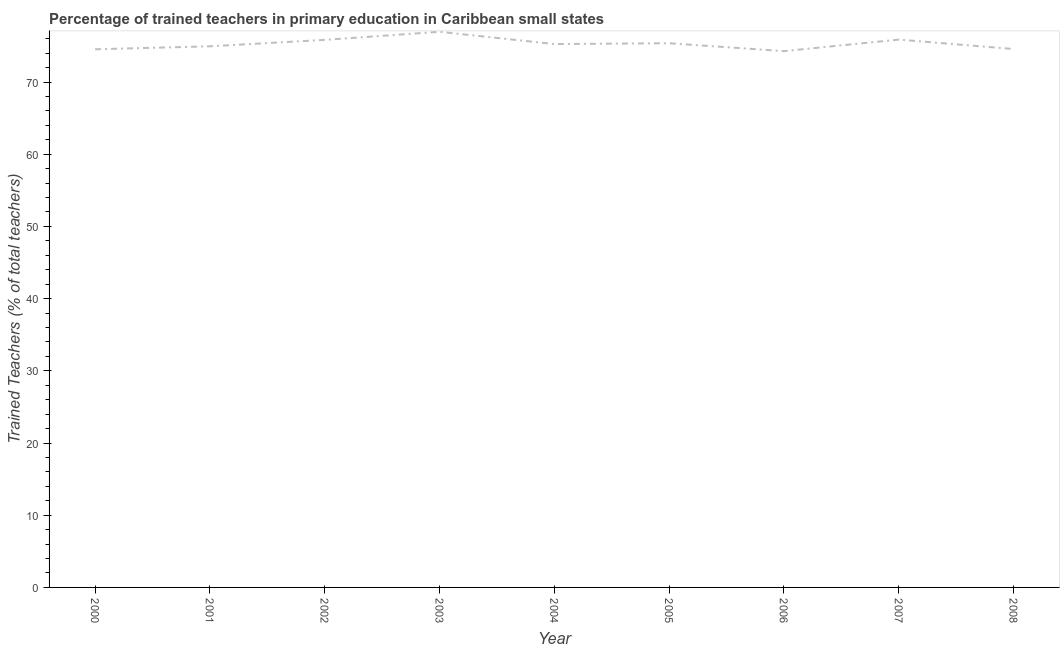What is the percentage of trained teachers in 2000?
Offer a terse response. 74.54. Across all years, what is the maximum percentage of trained teachers?
Offer a terse response. 76.96. Across all years, what is the minimum percentage of trained teachers?
Give a very brief answer. 74.28. What is the sum of the percentage of trained teachers?
Your response must be concise. 677.65. What is the difference between the percentage of trained teachers in 2004 and 2008?
Provide a short and direct response. 0.69. What is the average percentage of trained teachers per year?
Ensure brevity in your answer.  75.29. What is the median percentage of trained teachers?
Make the answer very short. 75.26. In how many years, is the percentage of trained teachers greater than 50 %?
Provide a succinct answer. 9. What is the ratio of the percentage of trained teachers in 2000 to that in 2003?
Your answer should be very brief. 0.97. Is the percentage of trained teachers in 2001 less than that in 2008?
Provide a succinct answer. No. What is the difference between the highest and the second highest percentage of trained teachers?
Provide a short and direct response. 1.08. Is the sum of the percentage of trained teachers in 2002 and 2006 greater than the maximum percentage of trained teachers across all years?
Your response must be concise. Yes. What is the difference between the highest and the lowest percentage of trained teachers?
Provide a succinct answer. 2.68. How many lines are there?
Offer a very short reply. 1. What is the difference between two consecutive major ticks on the Y-axis?
Your answer should be compact. 10. Are the values on the major ticks of Y-axis written in scientific E-notation?
Provide a succinct answer. No. What is the title of the graph?
Offer a terse response. Percentage of trained teachers in primary education in Caribbean small states. What is the label or title of the Y-axis?
Your response must be concise. Trained Teachers (% of total teachers). What is the Trained Teachers (% of total teachers) of 2000?
Provide a succinct answer. 74.54. What is the Trained Teachers (% of total teachers) in 2001?
Your answer should be compact. 74.95. What is the Trained Teachers (% of total teachers) of 2002?
Your answer should be very brief. 75.84. What is the Trained Teachers (% of total teachers) in 2003?
Give a very brief answer. 76.96. What is the Trained Teachers (% of total teachers) of 2004?
Your answer should be compact. 75.26. What is the Trained Teachers (% of total teachers) of 2005?
Your answer should be very brief. 75.38. What is the Trained Teachers (% of total teachers) in 2006?
Give a very brief answer. 74.28. What is the Trained Teachers (% of total teachers) in 2007?
Keep it short and to the point. 75.88. What is the Trained Teachers (% of total teachers) in 2008?
Your response must be concise. 74.57. What is the difference between the Trained Teachers (% of total teachers) in 2000 and 2001?
Provide a short and direct response. -0.41. What is the difference between the Trained Teachers (% of total teachers) in 2000 and 2002?
Provide a short and direct response. -1.3. What is the difference between the Trained Teachers (% of total teachers) in 2000 and 2003?
Keep it short and to the point. -2.42. What is the difference between the Trained Teachers (% of total teachers) in 2000 and 2004?
Ensure brevity in your answer.  -0.72. What is the difference between the Trained Teachers (% of total teachers) in 2000 and 2005?
Keep it short and to the point. -0.84. What is the difference between the Trained Teachers (% of total teachers) in 2000 and 2006?
Make the answer very short. 0.26. What is the difference between the Trained Teachers (% of total teachers) in 2000 and 2007?
Provide a succinct answer. -1.34. What is the difference between the Trained Teachers (% of total teachers) in 2000 and 2008?
Your answer should be compact. -0.04. What is the difference between the Trained Teachers (% of total teachers) in 2001 and 2002?
Your answer should be very brief. -0.89. What is the difference between the Trained Teachers (% of total teachers) in 2001 and 2003?
Your answer should be very brief. -2.01. What is the difference between the Trained Teachers (% of total teachers) in 2001 and 2004?
Give a very brief answer. -0.31. What is the difference between the Trained Teachers (% of total teachers) in 2001 and 2005?
Make the answer very short. -0.43. What is the difference between the Trained Teachers (% of total teachers) in 2001 and 2006?
Provide a short and direct response. 0.67. What is the difference between the Trained Teachers (% of total teachers) in 2001 and 2007?
Ensure brevity in your answer.  -0.93. What is the difference between the Trained Teachers (% of total teachers) in 2001 and 2008?
Offer a terse response. 0.37. What is the difference between the Trained Teachers (% of total teachers) in 2002 and 2003?
Ensure brevity in your answer.  -1.12. What is the difference between the Trained Teachers (% of total teachers) in 2002 and 2004?
Make the answer very short. 0.58. What is the difference between the Trained Teachers (% of total teachers) in 2002 and 2005?
Offer a terse response. 0.47. What is the difference between the Trained Teachers (% of total teachers) in 2002 and 2006?
Provide a short and direct response. 1.56. What is the difference between the Trained Teachers (% of total teachers) in 2002 and 2007?
Provide a short and direct response. -0.04. What is the difference between the Trained Teachers (% of total teachers) in 2002 and 2008?
Make the answer very short. 1.27. What is the difference between the Trained Teachers (% of total teachers) in 2003 and 2004?
Your answer should be very brief. 1.7. What is the difference between the Trained Teachers (% of total teachers) in 2003 and 2005?
Your response must be concise. 1.58. What is the difference between the Trained Teachers (% of total teachers) in 2003 and 2006?
Offer a terse response. 2.68. What is the difference between the Trained Teachers (% of total teachers) in 2003 and 2007?
Your answer should be compact. 1.08. What is the difference between the Trained Teachers (% of total teachers) in 2003 and 2008?
Offer a terse response. 2.38. What is the difference between the Trained Teachers (% of total teachers) in 2004 and 2005?
Your answer should be very brief. -0.12. What is the difference between the Trained Teachers (% of total teachers) in 2004 and 2006?
Give a very brief answer. 0.98. What is the difference between the Trained Teachers (% of total teachers) in 2004 and 2007?
Provide a succinct answer. -0.62. What is the difference between the Trained Teachers (% of total teachers) in 2004 and 2008?
Make the answer very short. 0.69. What is the difference between the Trained Teachers (% of total teachers) in 2005 and 2006?
Offer a terse response. 1.1. What is the difference between the Trained Teachers (% of total teachers) in 2005 and 2007?
Provide a succinct answer. -0.5. What is the difference between the Trained Teachers (% of total teachers) in 2005 and 2008?
Provide a short and direct response. 0.8. What is the difference between the Trained Teachers (% of total teachers) in 2006 and 2007?
Keep it short and to the point. -1.6. What is the difference between the Trained Teachers (% of total teachers) in 2006 and 2008?
Make the answer very short. -0.29. What is the difference between the Trained Teachers (% of total teachers) in 2007 and 2008?
Give a very brief answer. 1.3. What is the ratio of the Trained Teachers (% of total teachers) in 2000 to that in 2001?
Make the answer very short. 0.99. What is the ratio of the Trained Teachers (% of total teachers) in 2001 to that in 2002?
Your answer should be very brief. 0.99. What is the ratio of the Trained Teachers (% of total teachers) in 2001 to that in 2003?
Offer a very short reply. 0.97. What is the ratio of the Trained Teachers (% of total teachers) in 2001 to that in 2006?
Keep it short and to the point. 1.01. What is the ratio of the Trained Teachers (% of total teachers) in 2002 to that in 2003?
Your answer should be compact. 0.98. What is the ratio of the Trained Teachers (% of total teachers) in 2002 to that in 2004?
Your response must be concise. 1.01. What is the ratio of the Trained Teachers (% of total teachers) in 2002 to that in 2005?
Your response must be concise. 1.01. What is the ratio of the Trained Teachers (% of total teachers) in 2003 to that in 2004?
Provide a short and direct response. 1.02. What is the ratio of the Trained Teachers (% of total teachers) in 2003 to that in 2006?
Make the answer very short. 1.04. What is the ratio of the Trained Teachers (% of total teachers) in 2003 to that in 2007?
Provide a succinct answer. 1.01. What is the ratio of the Trained Teachers (% of total teachers) in 2003 to that in 2008?
Your answer should be very brief. 1.03. What is the ratio of the Trained Teachers (% of total teachers) in 2004 to that in 2006?
Provide a short and direct response. 1.01. What is the ratio of the Trained Teachers (% of total teachers) in 2004 to that in 2007?
Give a very brief answer. 0.99. What is the ratio of the Trained Teachers (% of total teachers) in 2005 to that in 2007?
Your answer should be very brief. 0.99. What is the ratio of the Trained Teachers (% of total teachers) in 2006 to that in 2007?
Offer a terse response. 0.98. 